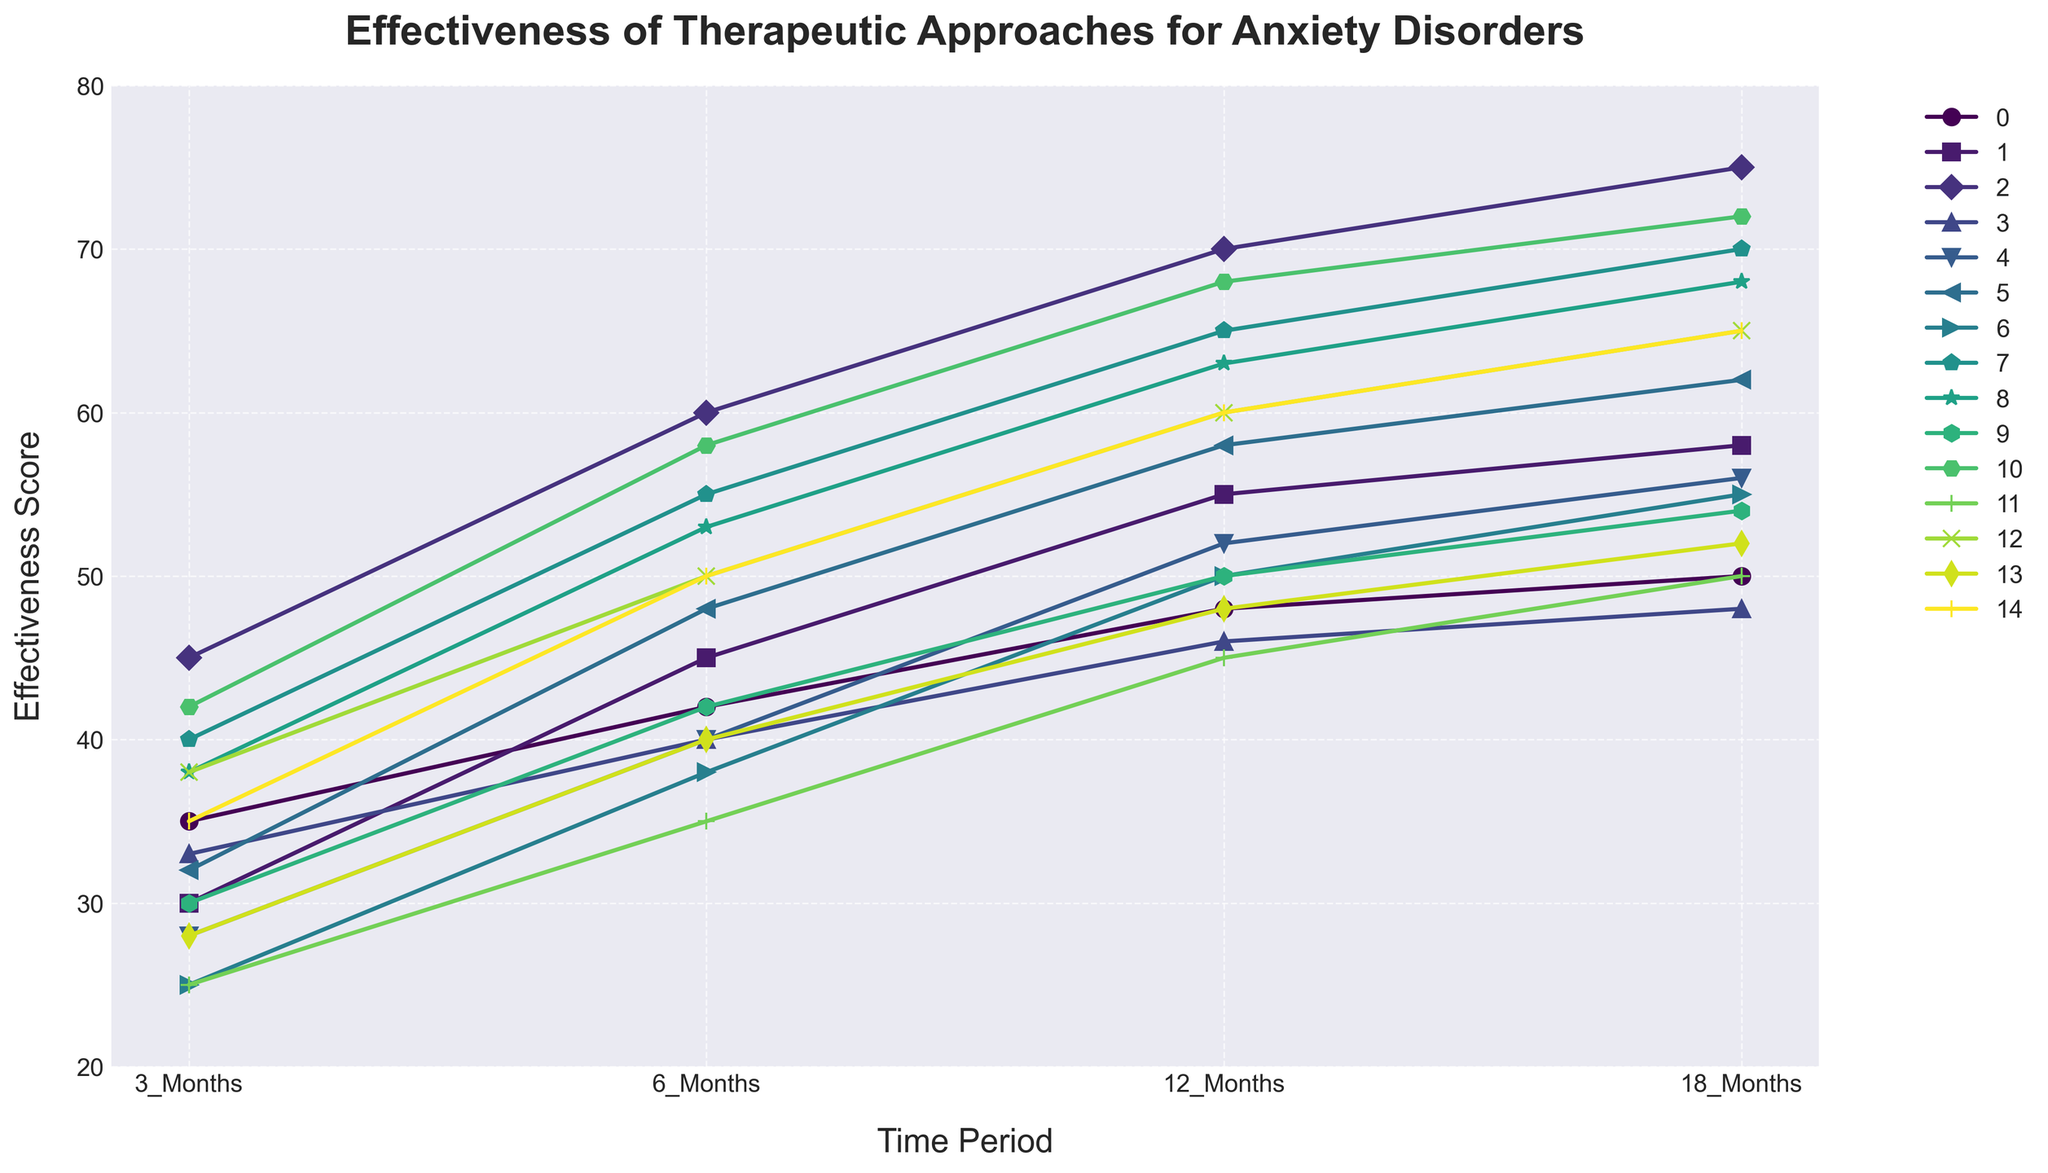What's the most effective treatment approach at the 18-month mark? The chart shows various treatment approaches over different time periods, and at the 18-month mark, the SSRI_and_CBT approach has the highest effectiveness score.
Answer: SSRI_and_CBT What is the difference in effectiveness between SSRIs_Only and SSRI_and_TMS at 12 months? At 12 months, SSRIs_Only has an effectiveness score of 48, while SSRI_and_TMS has an effectiveness score of 68. Subtracting these values gives the difference.
Answer: 20 How does the effectiveness of CBT_Only change from 6 months to 18 months? At 6 months, CBT_Only has an effectiveness score of 45, and at 18 months, it has a score of 58. The increase between these periods is calculated by subtracting 45 from 58.
Answer: 13 Which treatment approach shows the most consistent improvement over the entire period? By visually assessing the slopes of the lines for each treatment approach, SSRI_and_CBT and SSRI_and_TMS show the most consistent and steady improvements without any major drops or plateaus.
Answer: SSRI_and_CBT, SSRI_and_TMS Is Neurofeedback more effective than Medication_and_Group_Therapy at 3 months? At 3 months, Neurofeedback has an effectiveness score of 25, while Medication_and_Group_Therapy has a score of 38. Since 25 is less than 38, Neurofeedback is less effective.
Answer: No Which treatment has the steepest increase in effectiveness between 3 and 6 months? To determine this, compare the slopes of the segments between 3 and 6 months for all treatment approaches. EMDR has a sharp increase from 32 to 48, which is an increase of 16 points, the highest among all.
Answer: EMDR What is the average effectiveness score for Biofeedback across all time periods? Add the effectiveness scores for Biofeedback over all time periods (28 + 40 + 48 + 52) and divide by the number of time periods (4).
Answer: 42.5 Which treatment has the lowest effectiveness score at 6 months? By looking at the 6 months column, the lowest effectiveness score of 35 is for Psychodynamic_Therapy.
Answer: Psychodynamic_Therapy 